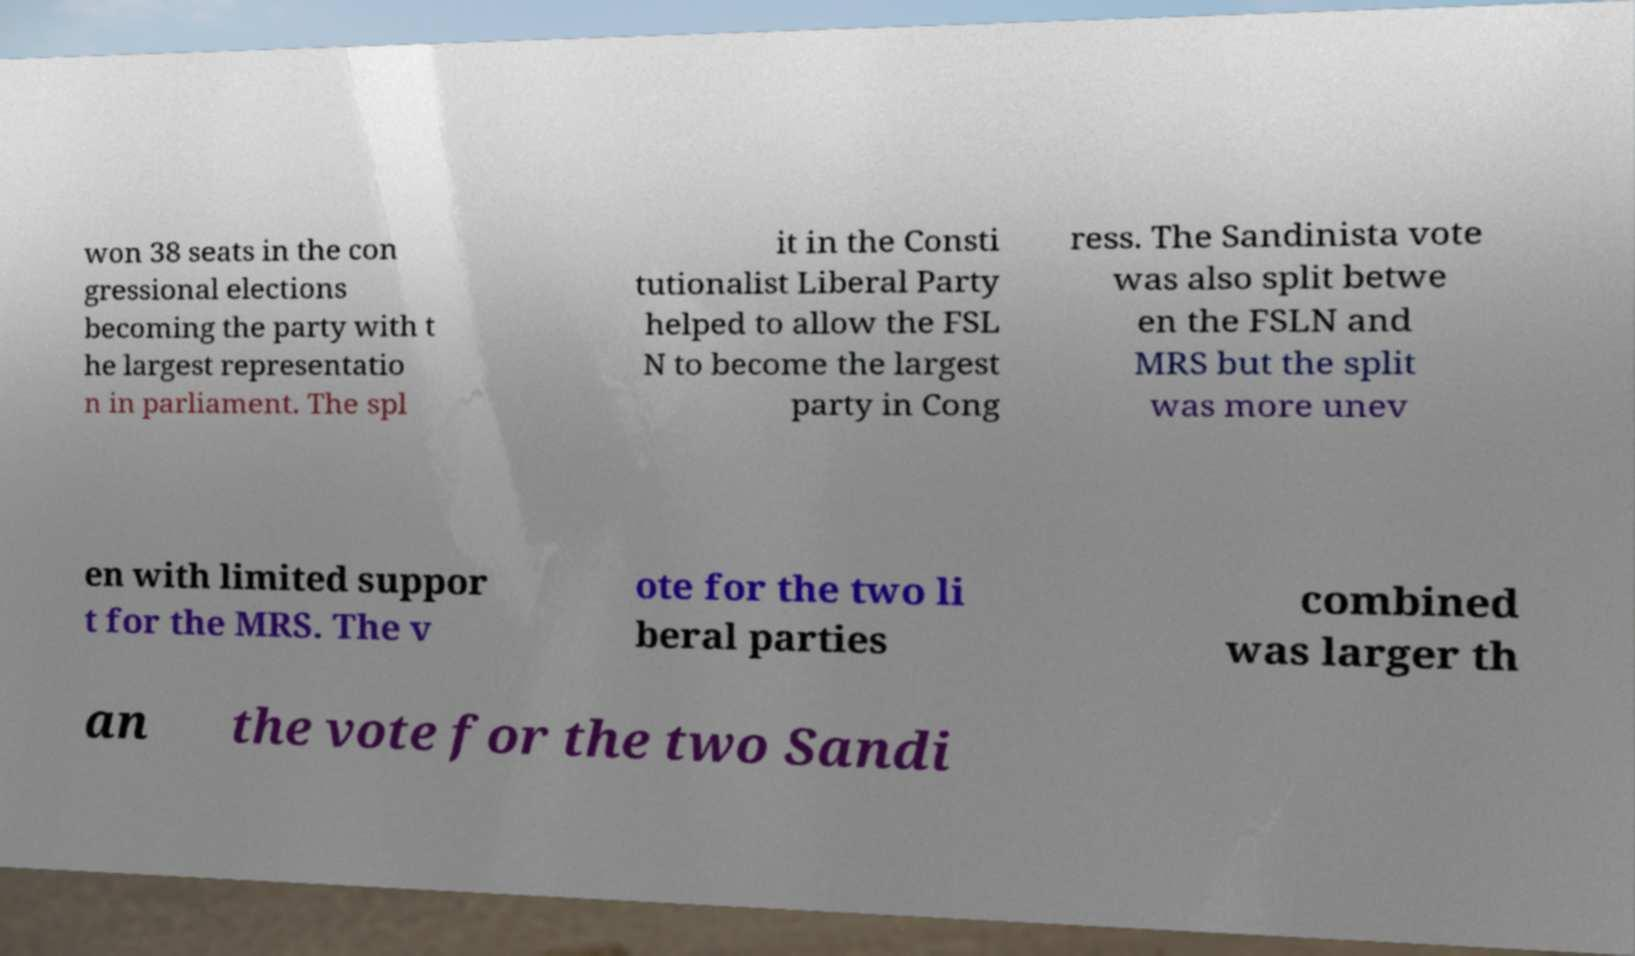Can you read and provide the text displayed in the image?This photo seems to have some interesting text. Can you extract and type it out for me? won 38 seats in the con gressional elections becoming the party with t he largest representatio n in parliament. The spl it in the Consti tutionalist Liberal Party helped to allow the FSL N to become the largest party in Cong ress. The Sandinista vote was also split betwe en the FSLN and MRS but the split was more unev en with limited suppor t for the MRS. The v ote for the two li beral parties combined was larger th an the vote for the two Sandi 